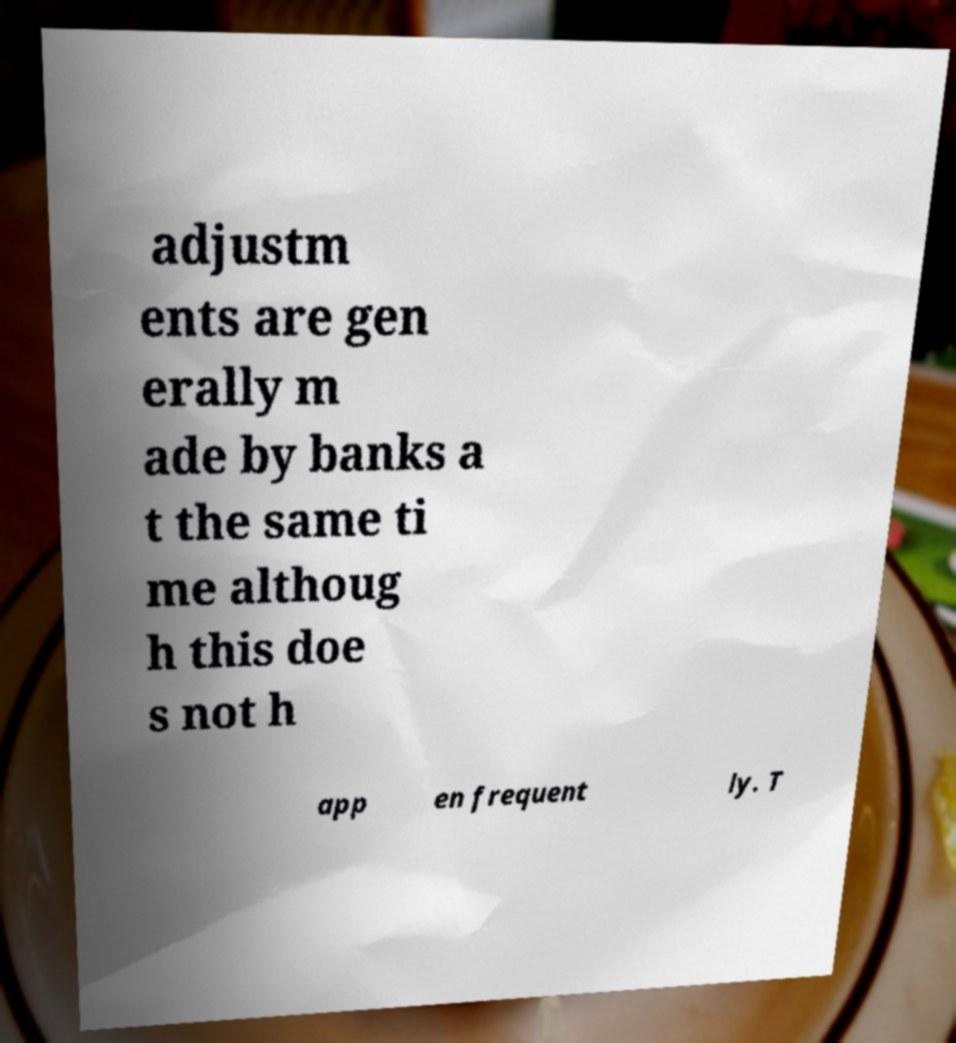I need the written content from this picture converted into text. Can you do that? adjustm ents are gen erally m ade by banks a t the same ti me althoug h this doe s not h app en frequent ly. T 